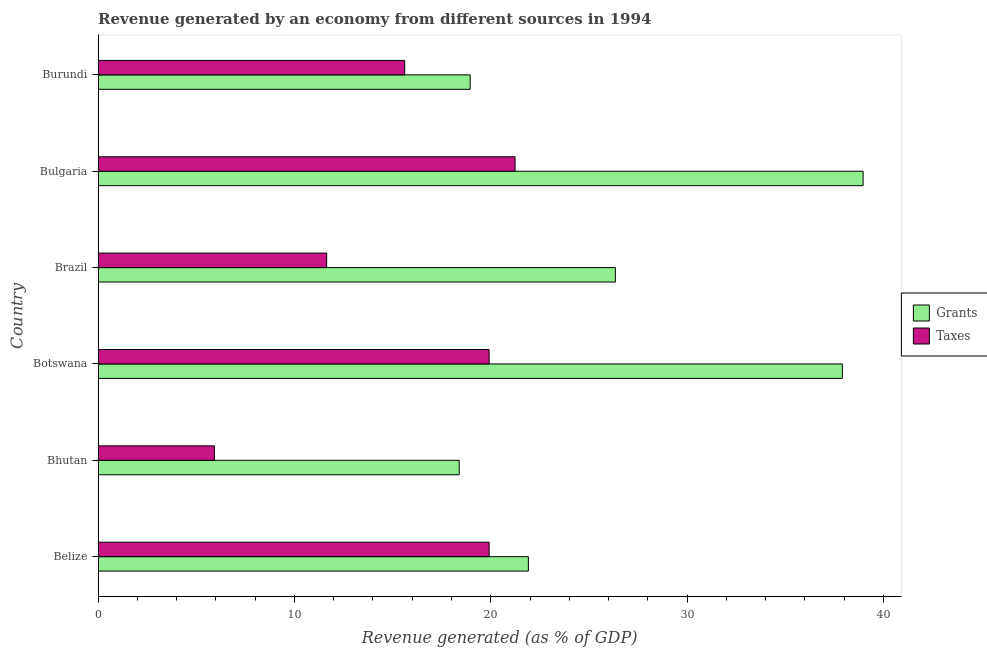How many groups of bars are there?
Your response must be concise. 6. Are the number of bars per tick equal to the number of legend labels?
Ensure brevity in your answer.  Yes. How many bars are there on the 4th tick from the top?
Your answer should be very brief. 2. What is the label of the 3rd group of bars from the top?
Ensure brevity in your answer.  Brazil. What is the revenue generated by grants in Burundi?
Ensure brevity in your answer.  18.95. Across all countries, what is the maximum revenue generated by taxes?
Keep it short and to the point. 21.24. Across all countries, what is the minimum revenue generated by taxes?
Offer a very short reply. 5.92. In which country was the revenue generated by grants maximum?
Provide a short and direct response. Bulgaria. In which country was the revenue generated by taxes minimum?
Your response must be concise. Bhutan. What is the total revenue generated by taxes in the graph?
Your answer should be very brief. 94.26. What is the difference between the revenue generated by grants in Belize and that in Botswana?
Ensure brevity in your answer.  -15.99. What is the difference between the revenue generated by taxes in Bulgaria and the revenue generated by grants in Belize?
Your answer should be compact. -0.68. What is the average revenue generated by grants per country?
Ensure brevity in your answer.  27.08. What is the difference between the revenue generated by grants and revenue generated by taxes in Brazil?
Give a very brief answer. 14.71. In how many countries, is the revenue generated by grants greater than 36 %?
Keep it short and to the point. 2. What is the ratio of the revenue generated by grants in Botswana to that in Brazil?
Provide a succinct answer. 1.44. What is the difference between the highest and the second highest revenue generated by taxes?
Ensure brevity in your answer.  1.32. What is the difference between the highest and the lowest revenue generated by taxes?
Your answer should be compact. 15.31. Is the sum of the revenue generated by taxes in Botswana and Bulgaria greater than the maximum revenue generated by grants across all countries?
Make the answer very short. Yes. What does the 2nd bar from the top in Belize represents?
Keep it short and to the point. Grants. What does the 2nd bar from the bottom in Burundi represents?
Your answer should be very brief. Taxes. How many bars are there?
Ensure brevity in your answer.  12. How many countries are there in the graph?
Ensure brevity in your answer.  6. What is the difference between two consecutive major ticks on the X-axis?
Give a very brief answer. 10. Does the graph contain any zero values?
Make the answer very short. No. How many legend labels are there?
Provide a short and direct response. 2. How are the legend labels stacked?
Your response must be concise. Vertical. What is the title of the graph?
Give a very brief answer. Revenue generated by an economy from different sources in 1994. What is the label or title of the X-axis?
Your response must be concise. Revenue generated (as % of GDP). What is the Revenue generated (as % of GDP) in Grants in Belize?
Give a very brief answer. 21.92. What is the Revenue generated (as % of GDP) of Taxes in Belize?
Your answer should be very brief. 19.92. What is the Revenue generated (as % of GDP) of Grants in Bhutan?
Your answer should be very brief. 18.39. What is the Revenue generated (as % of GDP) of Taxes in Bhutan?
Keep it short and to the point. 5.92. What is the Revenue generated (as % of GDP) in Grants in Botswana?
Your answer should be very brief. 37.91. What is the Revenue generated (as % of GDP) in Taxes in Botswana?
Make the answer very short. 19.92. What is the Revenue generated (as % of GDP) in Grants in Brazil?
Your answer should be compact. 26.35. What is the Revenue generated (as % of GDP) of Taxes in Brazil?
Make the answer very short. 11.64. What is the Revenue generated (as % of GDP) in Grants in Bulgaria?
Keep it short and to the point. 38.96. What is the Revenue generated (as % of GDP) in Taxes in Bulgaria?
Provide a short and direct response. 21.24. What is the Revenue generated (as % of GDP) of Grants in Burundi?
Keep it short and to the point. 18.95. What is the Revenue generated (as % of GDP) in Taxes in Burundi?
Keep it short and to the point. 15.62. Across all countries, what is the maximum Revenue generated (as % of GDP) of Grants?
Keep it short and to the point. 38.96. Across all countries, what is the maximum Revenue generated (as % of GDP) in Taxes?
Your answer should be compact. 21.24. Across all countries, what is the minimum Revenue generated (as % of GDP) of Grants?
Ensure brevity in your answer.  18.39. Across all countries, what is the minimum Revenue generated (as % of GDP) of Taxes?
Your answer should be very brief. 5.92. What is the total Revenue generated (as % of GDP) in Grants in the graph?
Ensure brevity in your answer.  162.48. What is the total Revenue generated (as % of GDP) of Taxes in the graph?
Your answer should be compact. 94.26. What is the difference between the Revenue generated (as % of GDP) in Grants in Belize and that in Bhutan?
Keep it short and to the point. 3.52. What is the difference between the Revenue generated (as % of GDP) of Taxes in Belize and that in Bhutan?
Offer a terse response. 13.99. What is the difference between the Revenue generated (as % of GDP) of Grants in Belize and that in Botswana?
Your answer should be very brief. -15.99. What is the difference between the Revenue generated (as % of GDP) in Taxes in Belize and that in Botswana?
Your response must be concise. -0. What is the difference between the Revenue generated (as % of GDP) in Grants in Belize and that in Brazil?
Provide a succinct answer. -4.43. What is the difference between the Revenue generated (as % of GDP) of Taxes in Belize and that in Brazil?
Your response must be concise. 8.27. What is the difference between the Revenue generated (as % of GDP) in Grants in Belize and that in Bulgaria?
Provide a succinct answer. -17.05. What is the difference between the Revenue generated (as % of GDP) of Taxes in Belize and that in Bulgaria?
Give a very brief answer. -1.32. What is the difference between the Revenue generated (as % of GDP) in Grants in Belize and that in Burundi?
Provide a succinct answer. 2.96. What is the difference between the Revenue generated (as % of GDP) in Taxes in Belize and that in Burundi?
Ensure brevity in your answer.  4.3. What is the difference between the Revenue generated (as % of GDP) of Grants in Bhutan and that in Botswana?
Keep it short and to the point. -19.51. What is the difference between the Revenue generated (as % of GDP) in Taxes in Bhutan and that in Botswana?
Keep it short and to the point. -13.99. What is the difference between the Revenue generated (as % of GDP) in Grants in Bhutan and that in Brazil?
Keep it short and to the point. -7.95. What is the difference between the Revenue generated (as % of GDP) of Taxes in Bhutan and that in Brazil?
Offer a very short reply. -5.72. What is the difference between the Revenue generated (as % of GDP) in Grants in Bhutan and that in Bulgaria?
Make the answer very short. -20.57. What is the difference between the Revenue generated (as % of GDP) of Taxes in Bhutan and that in Bulgaria?
Your answer should be compact. -15.31. What is the difference between the Revenue generated (as % of GDP) of Grants in Bhutan and that in Burundi?
Provide a succinct answer. -0.56. What is the difference between the Revenue generated (as % of GDP) in Taxes in Bhutan and that in Burundi?
Your answer should be compact. -9.69. What is the difference between the Revenue generated (as % of GDP) in Grants in Botswana and that in Brazil?
Your answer should be compact. 11.56. What is the difference between the Revenue generated (as % of GDP) of Taxes in Botswana and that in Brazil?
Offer a very short reply. 8.27. What is the difference between the Revenue generated (as % of GDP) of Grants in Botswana and that in Bulgaria?
Ensure brevity in your answer.  -1.06. What is the difference between the Revenue generated (as % of GDP) in Taxes in Botswana and that in Bulgaria?
Provide a succinct answer. -1.32. What is the difference between the Revenue generated (as % of GDP) in Grants in Botswana and that in Burundi?
Make the answer very short. 18.95. What is the difference between the Revenue generated (as % of GDP) of Taxes in Botswana and that in Burundi?
Your response must be concise. 4.3. What is the difference between the Revenue generated (as % of GDP) of Grants in Brazil and that in Bulgaria?
Give a very brief answer. -12.62. What is the difference between the Revenue generated (as % of GDP) of Taxes in Brazil and that in Bulgaria?
Make the answer very short. -9.6. What is the difference between the Revenue generated (as % of GDP) in Grants in Brazil and that in Burundi?
Your answer should be compact. 7.39. What is the difference between the Revenue generated (as % of GDP) in Taxes in Brazil and that in Burundi?
Your answer should be compact. -3.97. What is the difference between the Revenue generated (as % of GDP) of Grants in Bulgaria and that in Burundi?
Your answer should be very brief. 20.01. What is the difference between the Revenue generated (as % of GDP) of Taxes in Bulgaria and that in Burundi?
Give a very brief answer. 5.62. What is the difference between the Revenue generated (as % of GDP) in Grants in Belize and the Revenue generated (as % of GDP) in Taxes in Bhutan?
Keep it short and to the point. 15.99. What is the difference between the Revenue generated (as % of GDP) of Grants in Belize and the Revenue generated (as % of GDP) of Taxes in Botswana?
Your answer should be very brief. 2. What is the difference between the Revenue generated (as % of GDP) of Grants in Belize and the Revenue generated (as % of GDP) of Taxes in Brazil?
Give a very brief answer. 10.27. What is the difference between the Revenue generated (as % of GDP) in Grants in Belize and the Revenue generated (as % of GDP) in Taxes in Bulgaria?
Keep it short and to the point. 0.68. What is the difference between the Revenue generated (as % of GDP) of Grants in Belize and the Revenue generated (as % of GDP) of Taxes in Burundi?
Your answer should be very brief. 6.3. What is the difference between the Revenue generated (as % of GDP) in Grants in Bhutan and the Revenue generated (as % of GDP) in Taxes in Botswana?
Make the answer very short. -1.52. What is the difference between the Revenue generated (as % of GDP) in Grants in Bhutan and the Revenue generated (as % of GDP) in Taxes in Brazil?
Offer a very short reply. 6.75. What is the difference between the Revenue generated (as % of GDP) in Grants in Bhutan and the Revenue generated (as % of GDP) in Taxes in Bulgaria?
Your answer should be very brief. -2.85. What is the difference between the Revenue generated (as % of GDP) in Grants in Bhutan and the Revenue generated (as % of GDP) in Taxes in Burundi?
Ensure brevity in your answer.  2.78. What is the difference between the Revenue generated (as % of GDP) in Grants in Botswana and the Revenue generated (as % of GDP) in Taxes in Brazil?
Provide a succinct answer. 26.26. What is the difference between the Revenue generated (as % of GDP) in Grants in Botswana and the Revenue generated (as % of GDP) in Taxes in Bulgaria?
Offer a terse response. 16.67. What is the difference between the Revenue generated (as % of GDP) in Grants in Botswana and the Revenue generated (as % of GDP) in Taxes in Burundi?
Offer a terse response. 22.29. What is the difference between the Revenue generated (as % of GDP) of Grants in Brazil and the Revenue generated (as % of GDP) of Taxes in Bulgaria?
Provide a short and direct response. 5.11. What is the difference between the Revenue generated (as % of GDP) in Grants in Brazil and the Revenue generated (as % of GDP) in Taxes in Burundi?
Give a very brief answer. 10.73. What is the difference between the Revenue generated (as % of GDP) in Grants in Bulgaria and the Revenue generated (as % of GDP) in Taxes in Burundi?
Provide a short and direct response. 23.35. What is the average Revenue generated (as % of GDP) of Grants per country?
Your answer should be very brief. 27.08. What is the average Revenue generated (as % of GDP) of Taxes per country?
Keep it short and to the point. 15.71. What is the difference between the Revenue generated (as % of GDP) in Grants and Revenue generated (as % of GDP) in Taxes in Belize?
Make the answer very short. 2. What is the difference between the Revenue generated (as % of GDP) in Grants and Revenue generated (as % of GDP) in Taxes in Bhutan?
Your answer should be compact. 12.47. What is the difference between the Revenue generated (as % of GDP) in Grants and Revenue generated (as % of GDP) in Taxes in Botswana?
Keep it short and to the point. 17.99. What is the difference between the Revenue generated (as % of GDP) in Grants and Revenue generated (as % of GDP) in Taxes in Brazil?
Your answer should be very brief. 14.7. What is the difference between the Revenue generated (as % of GDP) in Grants and Revenue generated (as % of GDP) in Taxes in Bulgaria?
Offer a very short reply. 17.73. What is the difference between the Revenue generated (as % of GDP) in Grants and Revenue generated (as % of GDP) in Taxes in Burundi?
Make the answer very short. 3.34. What is the ratio of the Revenue generated (as % of GDP) of Grants in Belize to that in Bhutan?
Provide a succinct answer. 1.19. What is the ratio of the Revenue generated (as % of GDP) in Taxes in Belize to that in Bhutan?
Offer a terse response. 3.36. What is the ratio of the Revenue generated (as % of GDP) of Grants in Belize to that in Botswana?
Provide a succinct answer. 0.58. What is the ratio of the Revenue generated (as % of GDP) in Grants in Belize to that in Brazil?
Provide a succinct answer. 0.83. What is the ratio of the Revenue generated (as % of GDP) of Taxes in Belize to that in Brazil?
Offer a terse response. 1.71. What is the ratio of the Revenue generated (as % of GDP) of Grants in Belize to that in Bulgaria?
Give a very brief answer. 0.56. What is the ratio of the Revenue generated (as % of GDP) of Taxes in Belize to that in Bulgaria?
Your answer should be compact. 0.94. What is the ratio of the Revenue generated (as % of GDP) in Grants in Belize to that in Burundi?
Make the answer very short. 1.16. What is the ratio of the Revenue generated (as % of GDP) of Taxes in Belize to that in Burundi?
Give a very brief answer. 1.28. What is the ratio of the Revenue generated (as % of GDP) of Grants in Bhutan to that in Botswana?
Make the answer very short. 0.49. What is the ratio of the Revenue generated (as % of GDP) of Taxes in Bhutan to that in Botswana?
Provide a succinct answer. 0.3. What is the ratio of the Revenue generated (as % of GDP) in Grants in Bhutan to that in Brazil?
Your answer should be compact. 0.7. What is the ratio of the Revenue generated (as % of GDP) of Taxes in Bhutan to that in Brazil?
Ensure brevity in your answer.  0.51. What is the ratio of the Revenue generated (as % of GDP) in Grants in Bhutan to that in Bulgaria?
Give a very brief answer. 0.47. What is the ratio of the Revenue generated (as % of GDP) of Taxes in Bhutan to that in Bulgaria?
Keep it short and to the point. 0.28. What is the ratio of the Revenue generated (as % of GDP) in Grants in Bhutan to that in Burundi?
Offer a very short reply. 0.97. What is the ratio of the Revenue generated (as % of GDP) of Taxes in Bhutan to that in Burundi?
Provide a short and direct response. 0.38. What is the ratio of the Revenue generated (as % of GDP) in Grants in Botswana to that in Brazil?
Make the answer very short. 1.44. What is the ratio of the Revenue generated (as % of GDP) of Taxes in Botswana to that in Brazil?
Offer a very short reply. 1.71. What is the ratio of the Revenue generated (as % of GDP) in Grants in Botswana to that in Bulgaria?
Offer a very short reply. 0.97. What is the ratio of the Revenue generated (as % of GDP) in Taxes in Botswana to that in Bulgaria?
Offer a very short reply. 0.94. What is the ratio of the Revenue generated (as % of GDP) of Grants in Botswana to that in Burundi?
Ensure brevity in your answer.  2. What is the ratio of the Revenue generated (as % of GDP) in Taxes in Botswana to that in Burundi?
Your answer should be very brief. 1.28. What is the ratio of the Revenue generated (as % of GDP) of Grants in Brazil to that in Bulgaria?
Your answer should be very brief. 0.68. What is the ratio of the Revenue generated (as % of GDP) of Taxes in Brazil to that in Bulgaria?
Your answer should be very brief. 0.55. What is the ratio of the Revenue generated (as % of GDP) in Grants in Brazil to that in Burundi?
Your answer should be compact. 1.39. What is the ratio of the Revenue generated (as % of GDP) in Taxes in Brazil to that in Burundi?
Make the answer very short. 0.75. What is the ratio of the Revenue generated (as % of GDP) of Grants in Bulgaria to that in Burundi?
Keep it short and to the point. 2.06. What is the ratio of the Revenue generated (as % of GDP) of Taxes in Bulgaria to that in Burundi?
Provide a succinct answer. 1.36. What is the difference between the highest and the second highest Revenue generated (as % of GDP) of Grants?
Provide a succinct answer. 1.06. What is the difference between the highest and the second highest Revenue generated (as % of GDP) in Taxes?
Your answer should be compact. 1.32. What is the difference between the highest and the lowest Revenue generated (as % of GDP) of Grants?
Offer a very short reply. 20.57. What is the difference between the highest and the lowest Revenue generated (as % of GDP) of Taxes?
Offer a very short reply. 15.31. 